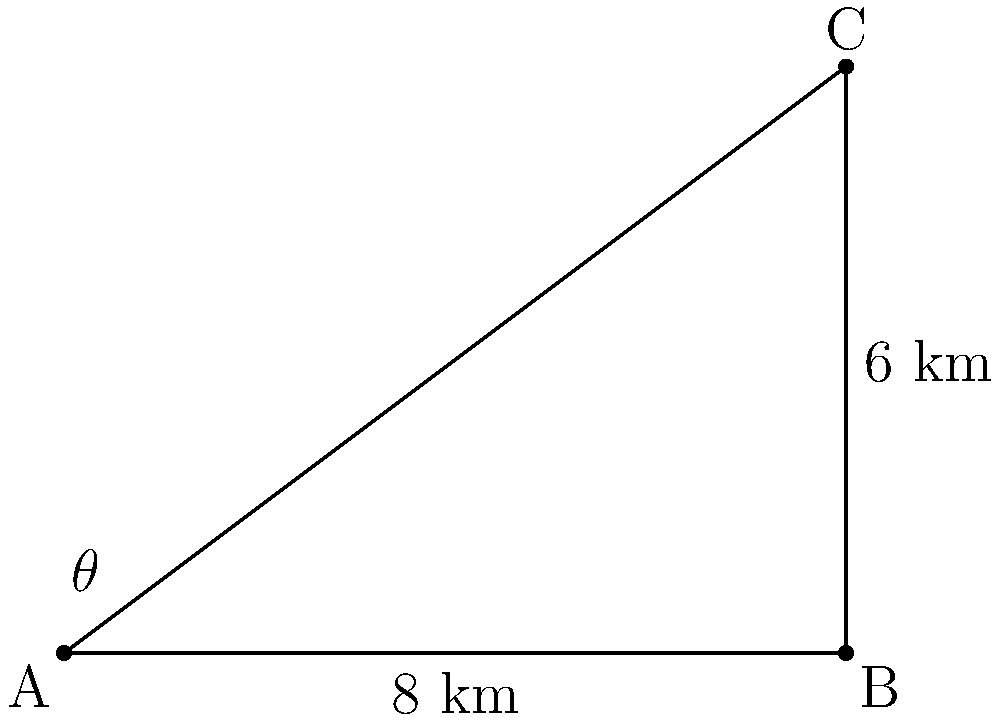As a community leader, you're planning an event that requires knowing the distance between two landmarks. From your office (point A), you can see both landmarks. One landmark (point B) is 8 km due east, while the other (point C) is visible at an angle of elevation of $\theta$ degrees from point B. If the vertical distance between points B and C is 6 km, what is the distance between the two landmarks (BC)? Let's approach this step-by-step:

1) We have a right-angled triangle ABC, where:
   - AB = 8 km (given)
   - BC is unknown (what we're solving for)
   - The vertical distance between B and C is 6 km

2) We can use the Pythagorean theorem to find BC:

   $BC^2 = AB^2 + BC_{vertical}^2$

3) Substituting the known values:

   $BC^2 = 8^2 + 6^2$

4) Simplify:

   $BC^2 = 64 + 36 = 100$

5) Take the square root of both sides:

   $BC = \sqrt{100} = 10$

Therefore, the distance between the two landmarks (BC) is 10 km.
Answer: 10 km 